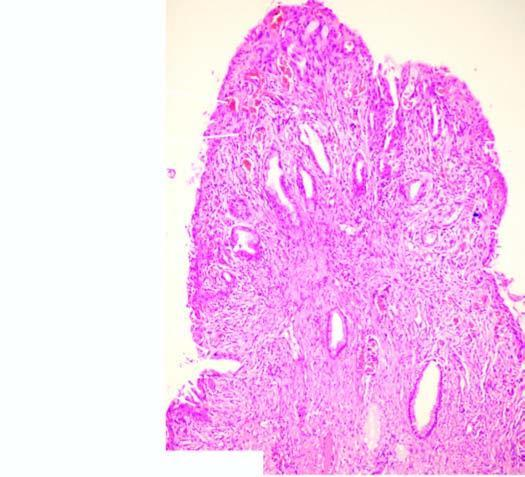s the surface covered by endocervical mucosa with squamous metaplasia?
Answer the question using a single word or phrase. Yes 